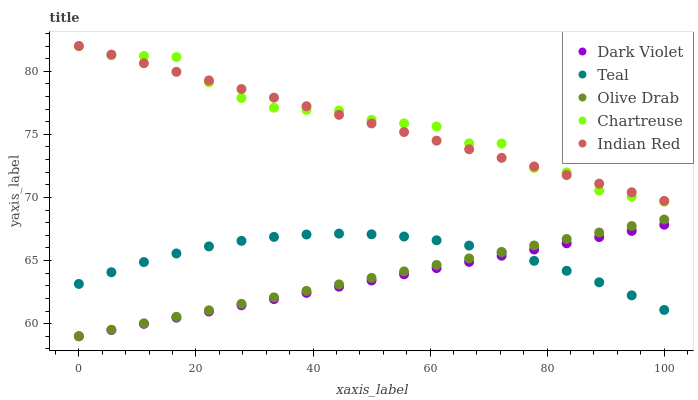Does Dark Violet have the minimum area under the curve?
Answer yes or no. Yes. Does Chartreuse have the maximum area under the curve?
Answer yes or no. Yes. Does Olive Drab have the minimum area under the curve?
Answer yes or no. No. Does Olive Drab have the maximum area under the curve?
Answer yes or no. No. Is Dark Violet the smoothest?
Answer yes or no. Yes. Is Chartreuse the roughest?
Answer yes or no. Yes. Is Olive Drab the smoothest?
Answer yes or no. No. Is Olive Drab the roughest?
Answer yes or no. No. Does Olive Drab have the lowest value?
Answer yes or no. Yes. Does Chartreuse have the lowest value?
Answer yes or no. No. Does Chartreuse have the highest value?
Answer yes or no. Yes. Does Olive Drab have the highest value?
Answer yes or no. No. Is Olive Drab less than Indian Red?
Answer yes or no. Yes. Is Indian Red greater than Teal?
Answer yes or no. Yes. Does Olive Drab intersect Teal?
Answer yes or no. Yes. Is Olive Drab less than Teal?
Answer yes or no. No. Is Olive Drab greater than Teal?
Answer yes or no. No. Does Olive Drab intersect Indian Red?
Answer yes or no. No. 